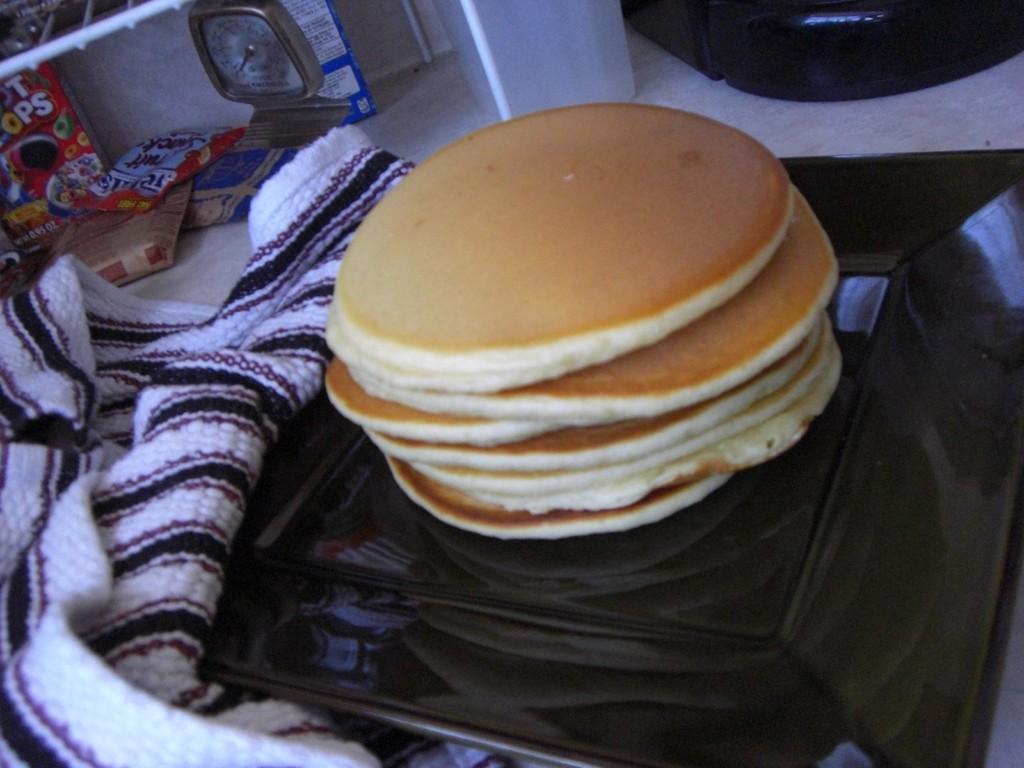Can you describe this image briefly? In this image in the center there are some pancakes on a stove, and there is one cloth. In the background there is clock and some packets and some objects, at the bottom there is floor. 